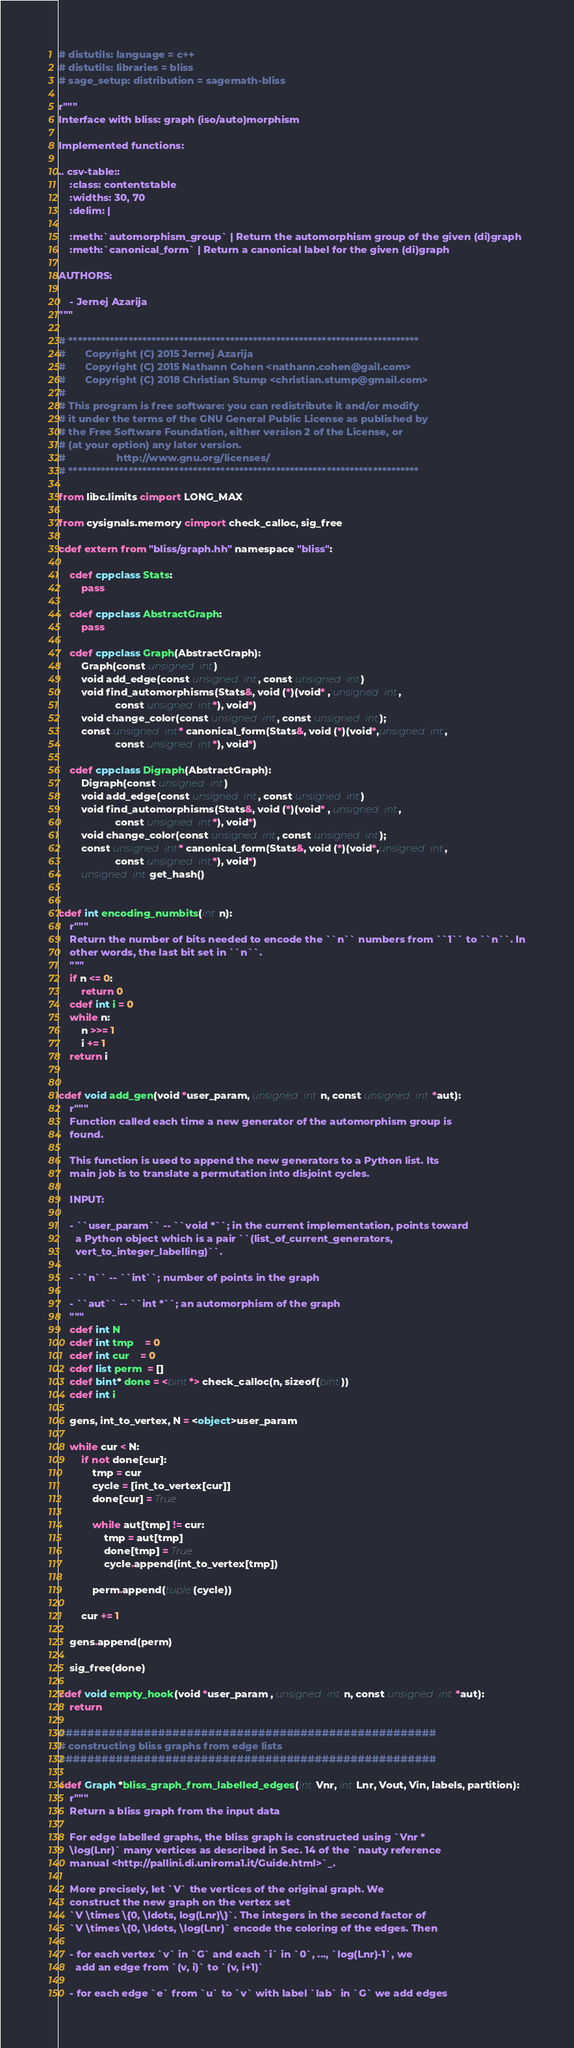Convert code to text. <code><loc_0><loc_0><loc_500><loc_500><_Cython_># distutils: language = c++
# distutils: libraries = bliss
# sage_setup: distribution = sagemath-bliss

r"""
Interface with bliss: graph (iso/auto)morphism

Implemented functions:

.. csv-table::
    :class: contentstable
    :widths: 30, 70
    :delim: |

    :meth:`automorphism_group` | Return the automorphism group of the given (di)graph
    :meth:`canonical_form` | Return a canonical label for the given (di)graph

AUTHORS:

    - Jernej Azarija
"""

# ****************************************************************************
#       Copyright (C) 2015 Jernej Azarija
#       Copyright (C) 2015 Nathann Cohen <nathann.cohen@gail.com>
#       Copyright (C) 2018 Christian Stump <christian.stump@gmail.com>
#
# This program is free software: you can redistribute it and/or modify
# it under the terms of the GNU General Public License as published by
# the Free Software Foundation, either version 2 of the License, or
# (at your option) any later version.
#                  http://www.gnu.org/licenses/
# ****************************************************************************

from libc.limits cimport LONG_MAX

from cysignals.memory cimport check_calloc, sig_free

cdef extern from "bliss/graph.hh" namespace "bliss":

    cdef cppclass Stats:
        pass

    cdef cppclass AbstractGraph:
        pass

    cdef cppclass Graph(AbstractGraph):
        Graph(const unsigned int)
        void add_edge(const unsigned int, const unsigned int)
        void find_automorphisms(Stats&, void (*)(void* , unsigned int,
                    const unsigned int*), void*)
        void change_color(const unsigned int, const unsigned int);
        const unsigned int* canonical_form(Stats&, void (*)(void*,unsigned int,
                    const unsigned int*), void*)

    cdef cppclass Digraph(AbstractGraph):
        Digraph(const unsigned int)
        void add_edge(const unsigned int, const unsigned int)
        void find_automorphisms(Stats&, void (*)(void* , unsigned int,
                    const unsigned int*), void*)
        void change_color(const unsigned int, const unsigned int);
        const unsigned int* canonical_form(Stats&, void (*)(void*,unsigned int,
                    const unsigned int*), void*)
        unsigned int get_hash()


cdef int encoding_numbits(int n):
    r"""
    Return the number of bits needed to encode the ``n`` numbers from ``1`` to ``n``. In
    other words, the last bit set in ``n``.
    """
    if n <= 0:
        return 0
    cdef int i = 0
    while n:
        n >>= 1
        i += 1
    return i


cdef void add_gen(void *user_param, unsigned int n, const unsigned int *aut):
    r"""
    Function called each time a new generator of the automorphism group is
    found.

    This function is used to append the new generators to a Python list. Its
    main job is to translate a permutation into disjoint cycles.

    INPUT:

    - ``user_param`` -- ``void *``; in the current implementation, points toward
      a Python object which is a pair ``(list_of_current_generators,
      vert_to_integer_labelling)``.

    - ``n`` -- ``int``; number of points in the graph

    - ``aut`` -- ``int *``; an automorphism of the graph
    """
    cdef int N
    cdef int tmp    = 0
    cdef int cur    = 0
    cdef list perm  = []
    cdef bint* done = <bint*> check_calloc(n, sizeof(bint))
    cdef int i

    gens, int_to_vertex, N = <object>user_param

    while cur < N:
        if not done[cur]:
            tmp = cur
            cycle = [int_to_vertex[cur]]
            done[cur] = True

            while aut[tmp] != cur:
                tmp = aut[tmp]
                done[tmp] = True
                cycle.append(int_to_vertex[tmp])

            perm.append(tuple(cycle))

        cur += 1

    gens.append(perm)

    sig_free(done)

cdef void empty_hook(void *user_param , unsigned int n, const unsigned int *aut):
    return

#####################################################
# constructing bliss graphs from edge lists
#####################################################

cdef Graph *bliss_graph_from_labelled_edges(int Vnr, int Lnr, Vout, Vin, labels, partition):
    r"""
    Return a bliss graph from the input data

    For edge labelled graphs, the bliss graph is constructed using `Vnr *
    \log(Lnr)` many vertices as described in Sec. 14 of the `nauty reference
    manual <http://pallini.di.uniroma1.it/Guide.html>`_.

    More precisely, let `V` the vertices of the original graph. We
    construct the new graph on the vertex set
    `V \times \{0, \ldots, log(Lnr)\}`. The integers in the second factor of
    `V \times \{0, \ldots, \log(Lnr)` encode the coloring of the edges. Then

    - for each vertex `v` in `G` and each `i` in `0`, ..., `log(Lnr)-1`, we
      add an edge from `(v, i)` to `(v, i+1)`

    - for each edge `e` from `u` to `v` with label `lab` in `G` we add edges</code> 